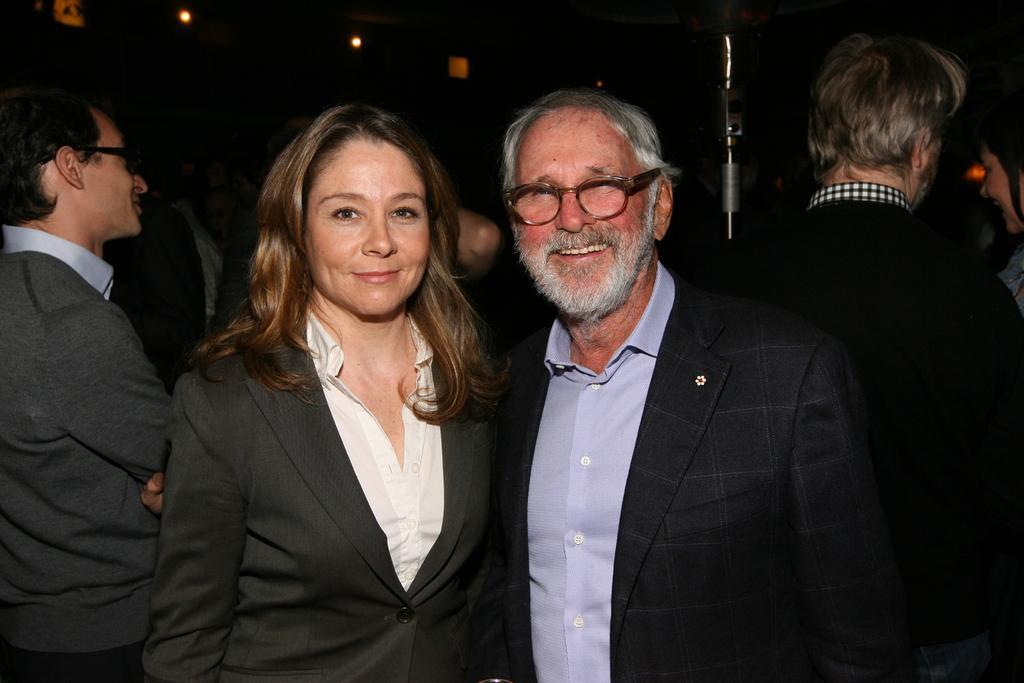Can you describe this image briefly? In the image we can see there are people standing and they are wearing formal suits. 